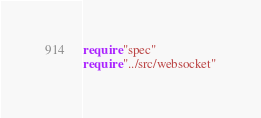<code> <loc_0><loc_0><loc_500><loc_500><_Crystal_>require "spec"
require "../src/websocket"
</code> 